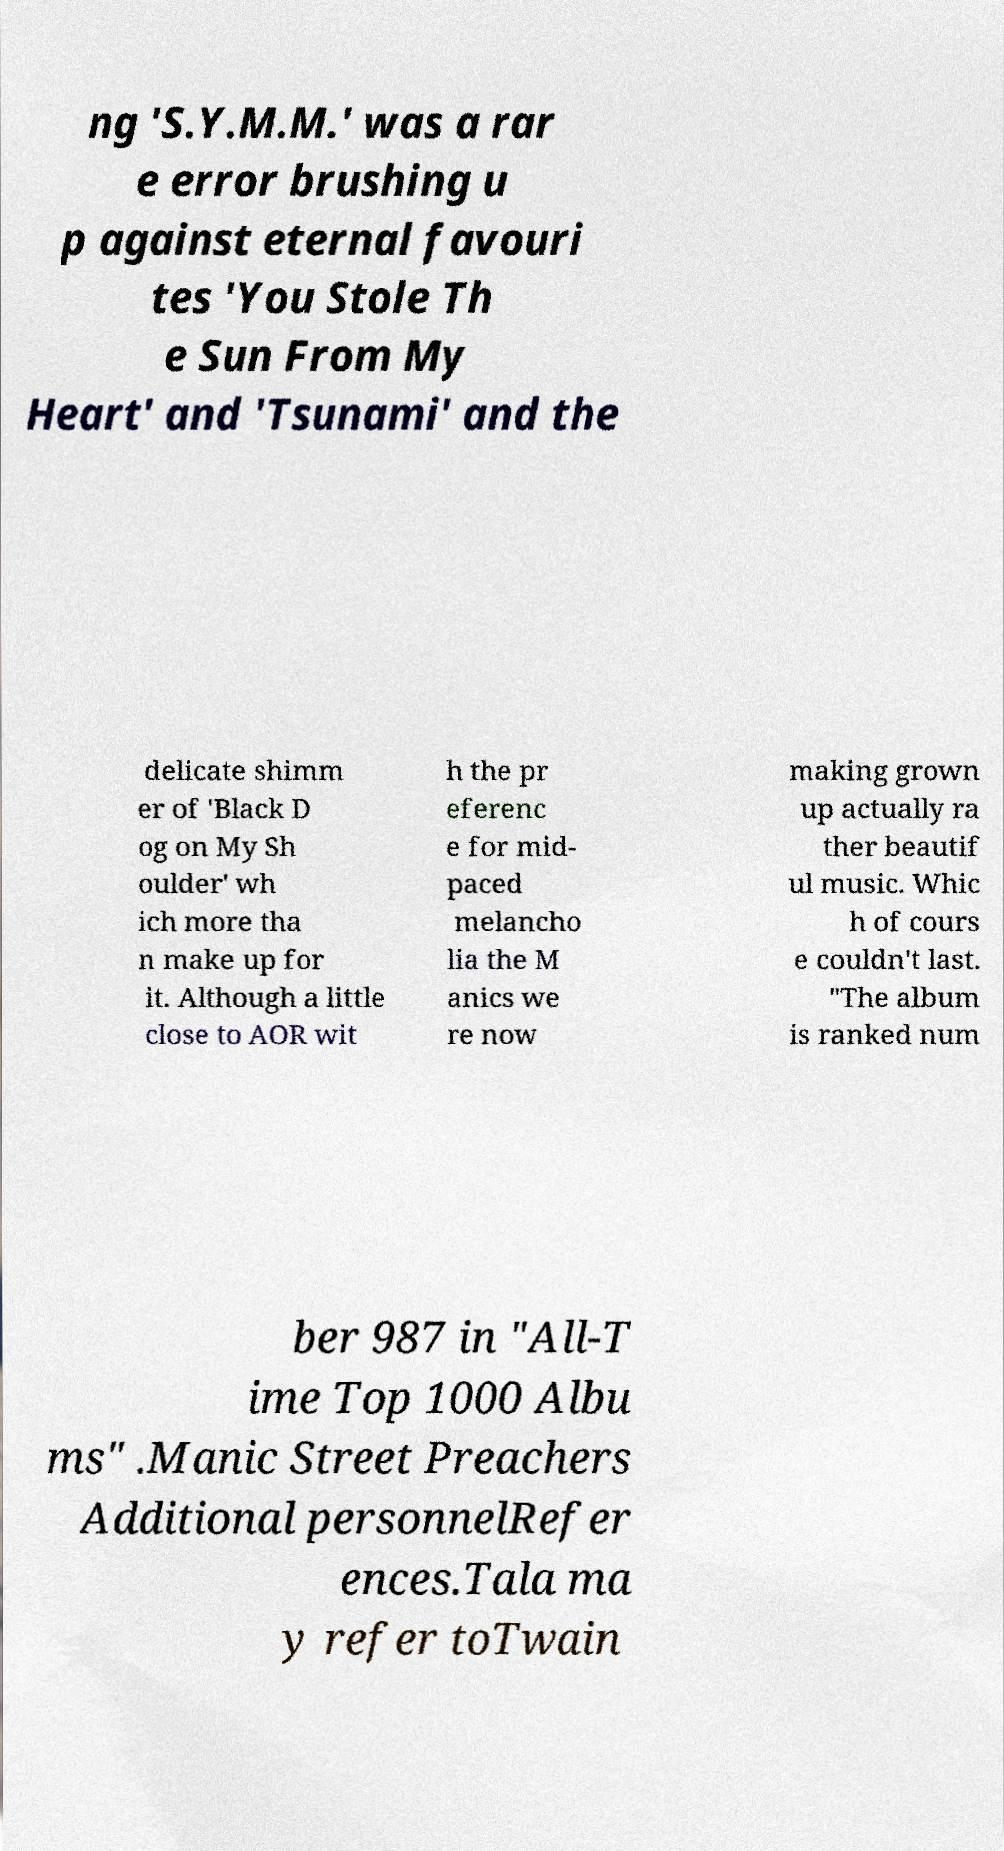Can you accurately transcribe the text from the provided image for me? ng 'S.Y.M.M.' was a rar e error brushing u p against eternal favouri tes 'You Stole Th e Sun From My Heart' and 'Tsunami' and the delicate shimm er of 'Black D og on My Sh oulder' wh ich more tha n make up for it. Although a little close to AOR wit h the pr eferenc e for mid- paced melancho lia the M anics we re now making grown up actually ra ther beautif ul music. Whic h of cours e couldn't last. "The album is ranked num ber 987 in "All-T ime Top 1000 Albu ms" .Manic Street Preachers Additional personnelRefer ences.Tala ma y refer toTwain 